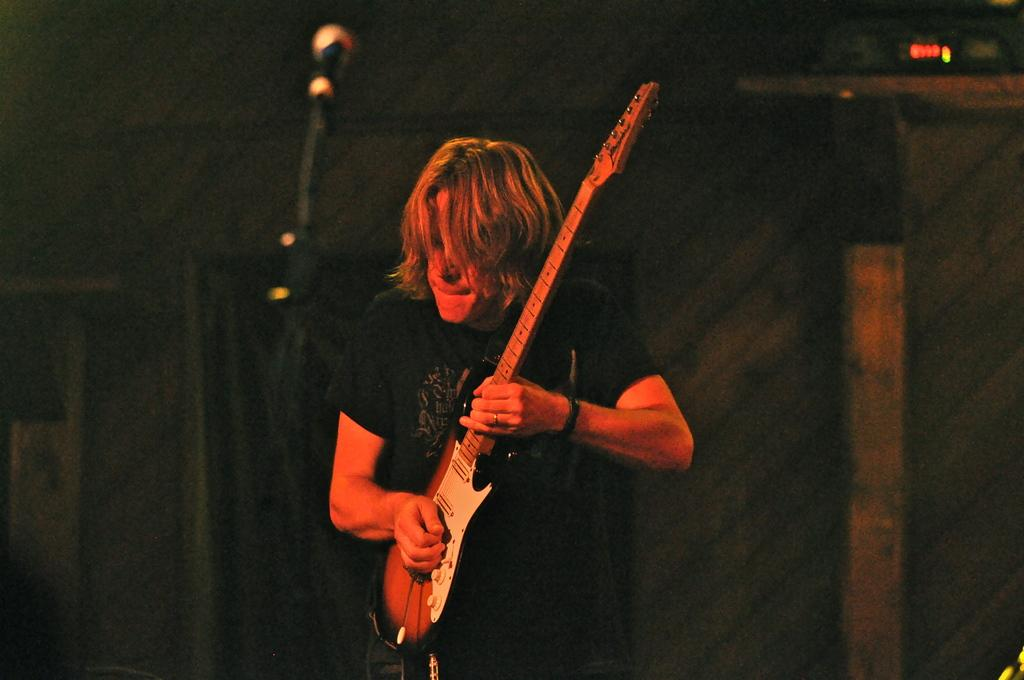What is the man in the image doing? The man is playing a guitar in the image. Can you describe the man's surroundings in the image? The background of the man is blurred in the image. How many trucks are visible in the image? There are no trucks visible in the image; it only features a man playing a guitar. Is the horse in the image wearing a saddle? There is no horse present in the image. 